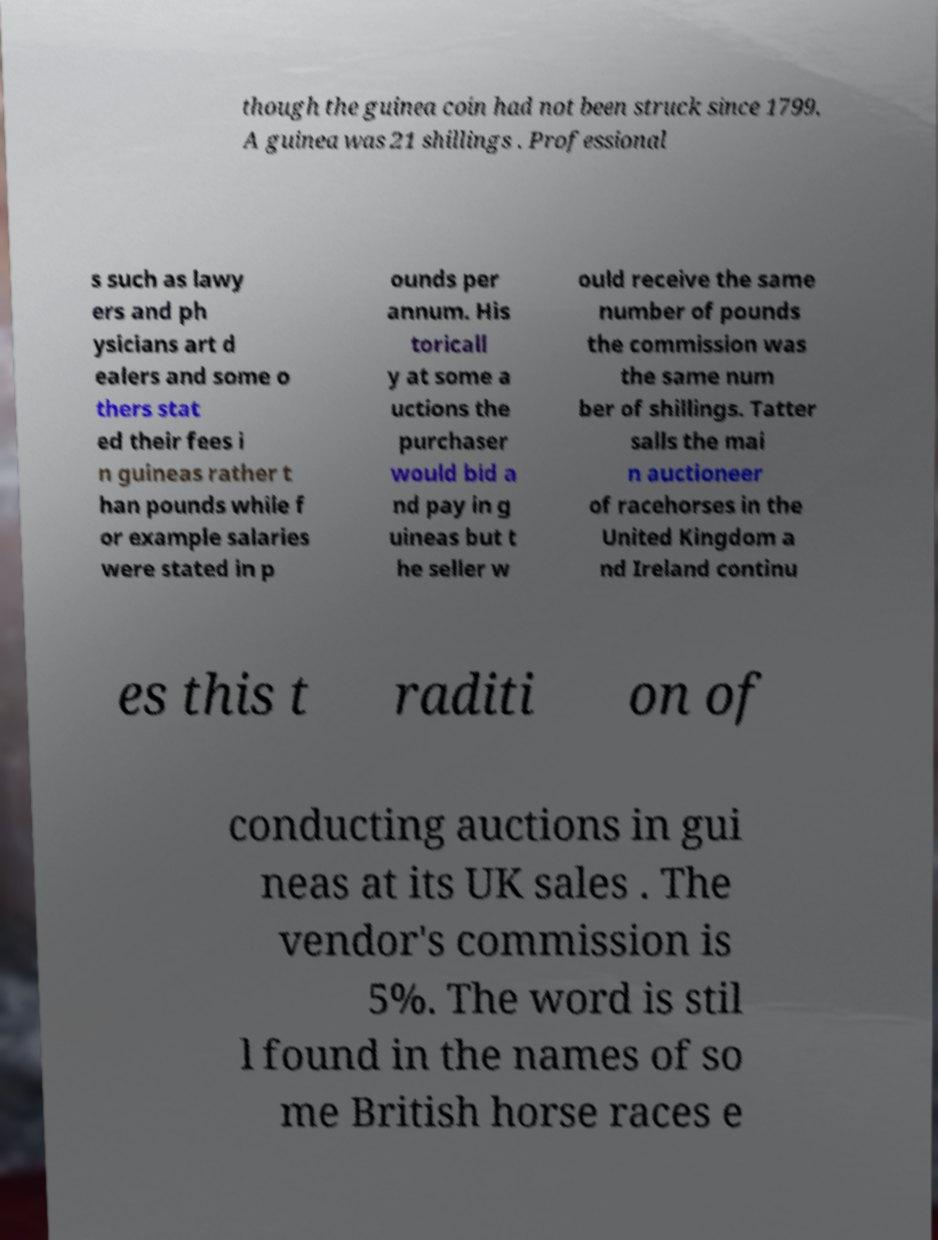I need the written content from this picture converted into text. Can you do that? though the guinea coin had not been struck since 1799. A guinea was 21 shillings . Professional s such as lawy ers and ph ysicians art d ealers and some o thers stat ed their fees i n guineas rather t han pounds while f or example salaries were stated in p ounds per annum. His toricall y at some a uctions the purchaser would bid a nd pay in g uineas but t he seller w ould receive the same number of pounds the commission was the same num ber of shillings. Tatter salls the mai n auctioneer of racehorses in the United Kingdom a nd Ireland continu es this t raditi on of conducting auctions in gui neas at its UK sales . The vendor's commission is 5%. The word is stil l found in the names of so me British horse races e 